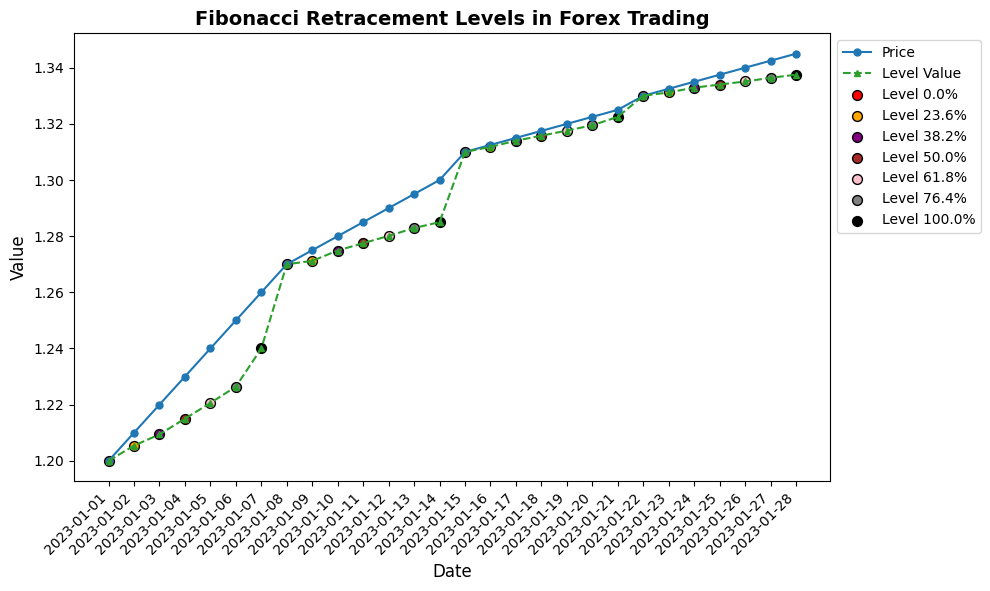What is the price on 2023-01-10? According to the figure, find the corresponding 'Price' value for the date 2023-01-10.
Answer: 1.2800 Which date corresponds to the highest Level Value? Observe the 'Level Value' series and identify the date where it reaches its maximum. The highest Level Value occurs on 2023-01-28 with a value of 1.3375.
Answer: 2023-01-28 How does the price on 2023-01-05 compare to the Level Value on the same date? Compare the 'Price' value and the 'Level Value' for the date 2023-01-05. The price is 1.2400 and the Level Value is 1.2206. Since 1.2400 > 1.2206, the price is higher.
Answer: Price is higher Which Level Values align with the price of 1.2500? Identify the 'Level Value' points that coincide with the price of 1.2500 on the figure. The Level Value for the price 1.2500 on 2023-01-06 is 1.2264.
Answer: 1.2264 What is the difference between the Level Value on 2023-01-03 and 2023-01-07? Calculate the difference between the Level Values on the given dates. On 2023-01-03, the Level Value is 1.2094, and on 2023-01-07, it is 1.2400. The difference is 1.2400 - 1.2094 = 0.0306.
Answer: 0.0306 How do the Level Values change between 23.6% and 50.0% levels for the date 2023-01-16? Identify the Level Values at 23.6% (1.3118) and 50.0% (1.3158) for 2023-01-16 and calculate the change. The change is 1.3158 - 1.3118 = 0.004.
Answer: 0.004 Compare the Level Values for 23.6% and 61.8% levels on 2023-01-02 and determine which is higher. Check the 'Level_Value' for 23.6% (1.2054) and 61.8% (1.2206). Since 1.2206 > 1.2054, the 61.8% Level Value is higher.
Answer: 61.8% Level is higher What color is used to represent the Level Value for the 76.4% level? The figure uses specific colors to represent different Fibonacci levels. Identify the color assigned to the 76.4% Level Value, which is gray.
Answer: gray Calculate the average Level Value on 2023-01-01 and 2023-01-02. Add the Level Values of both dates and divide by 2. For 2023-01-01, the Level Value is 1.2000, and for 2023-01-02, it is 1.2054. The average is (1.2000 + 1.2054) / 2 = 1.2027.
Answer: 1.2027 